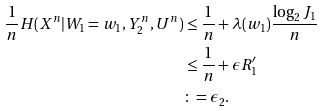Convert formula to latex. <formula><loc_0><loc_0><loc_500><loc_500>\frac { 1 } { n } H ( X ^ { n } | W _ { 1 } = w _ { 1 } , Y _ { 2 } ^ { n } , U ^ { n } ) & \leq \frac { 1 } { n } + \lambda ( w _ { 1 } ) \frac { \log _ { 2 } J _ { 1 } } { n } \\ & \leq \frac { 1 } { n } + \epsilon R ^ { \prime } _ { 1 } \\ & \colon = \epsilon _ { 2 } .</formula> 